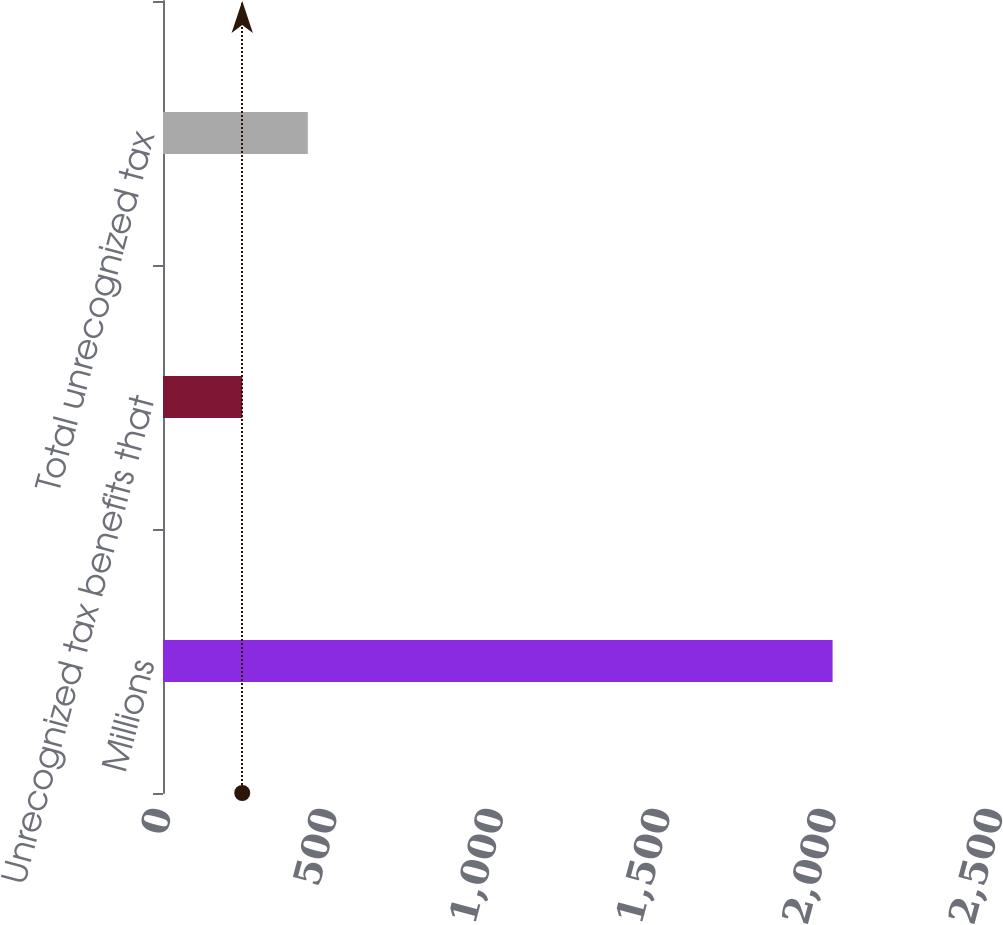Convert chart to OTSL. <chart><loc_0><loc_0><loc_500><loc_500><bar_chart><fcel>Millions<fcel>Unrecognized tax benefits that<fcel>Total unrecognized tax<nl><fcel>2012<fcel>238.1<fcel>435.2<nl></chart> 